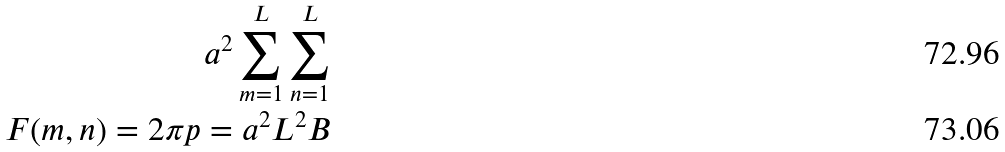<formula> <loc_0><loc_0><loc_500><loc_500>a ^ { 2 } \sum _ { m = 1 } ^ { L } \sum _ { n = 1 } ^ { L } \\ F ( m , n ) = 2 \pi p = a ^ { 2 } L ^ { 2 } B</formula> 